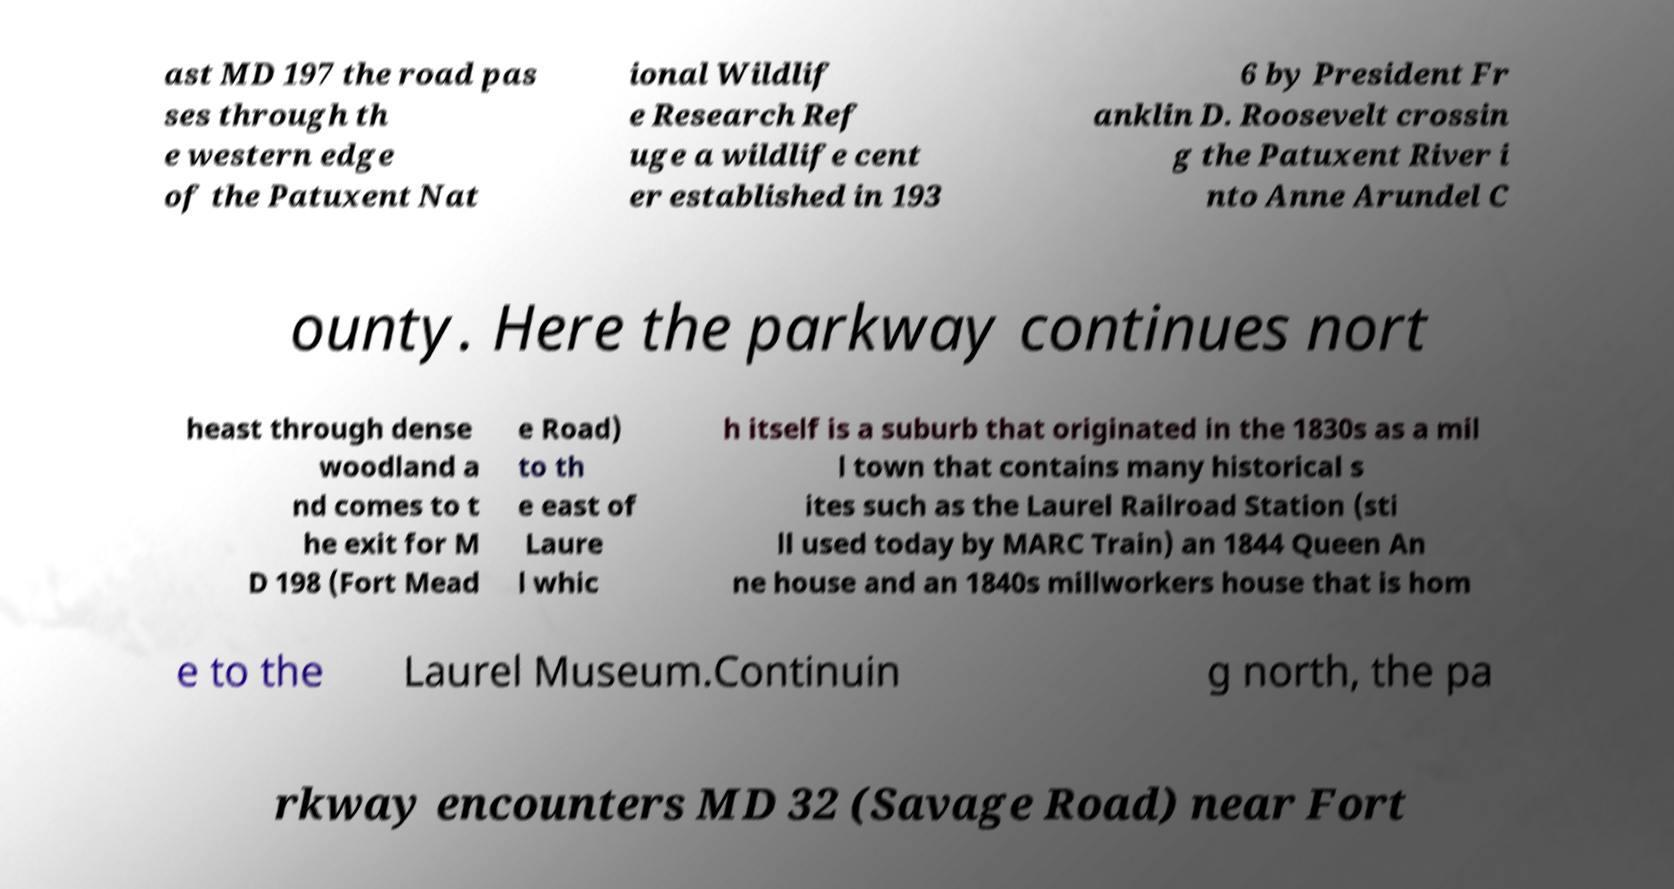Please identify and transcribe the text found in this image. ast MD 197 the road pas ses through th e western edge of the Patuxent Nat ional Wildlif e Research Ref uge a wildlife cent er established in 193 6 by President Fr anklin D. Roosevelt crossin g the Patuxent River i nto Anne Arundel C ounty. Here the parkway continues nort heast through dense woodland a nd comes to t he exit for M D 198 (Fort Mead e Road) to th e east of Laure l whic h itself is a suburb that originated in the 1830s as a mil l town that contains many historical s ites such as the Laurel Railroad Station (sti ll used today by MARC Train) an 1844 Queen An ne house and an 1840s millworkers house that is hom e to the Laurel Museum.Continuin g north, the pa rkway encounters MD 32 (Savage Road) near Fort 